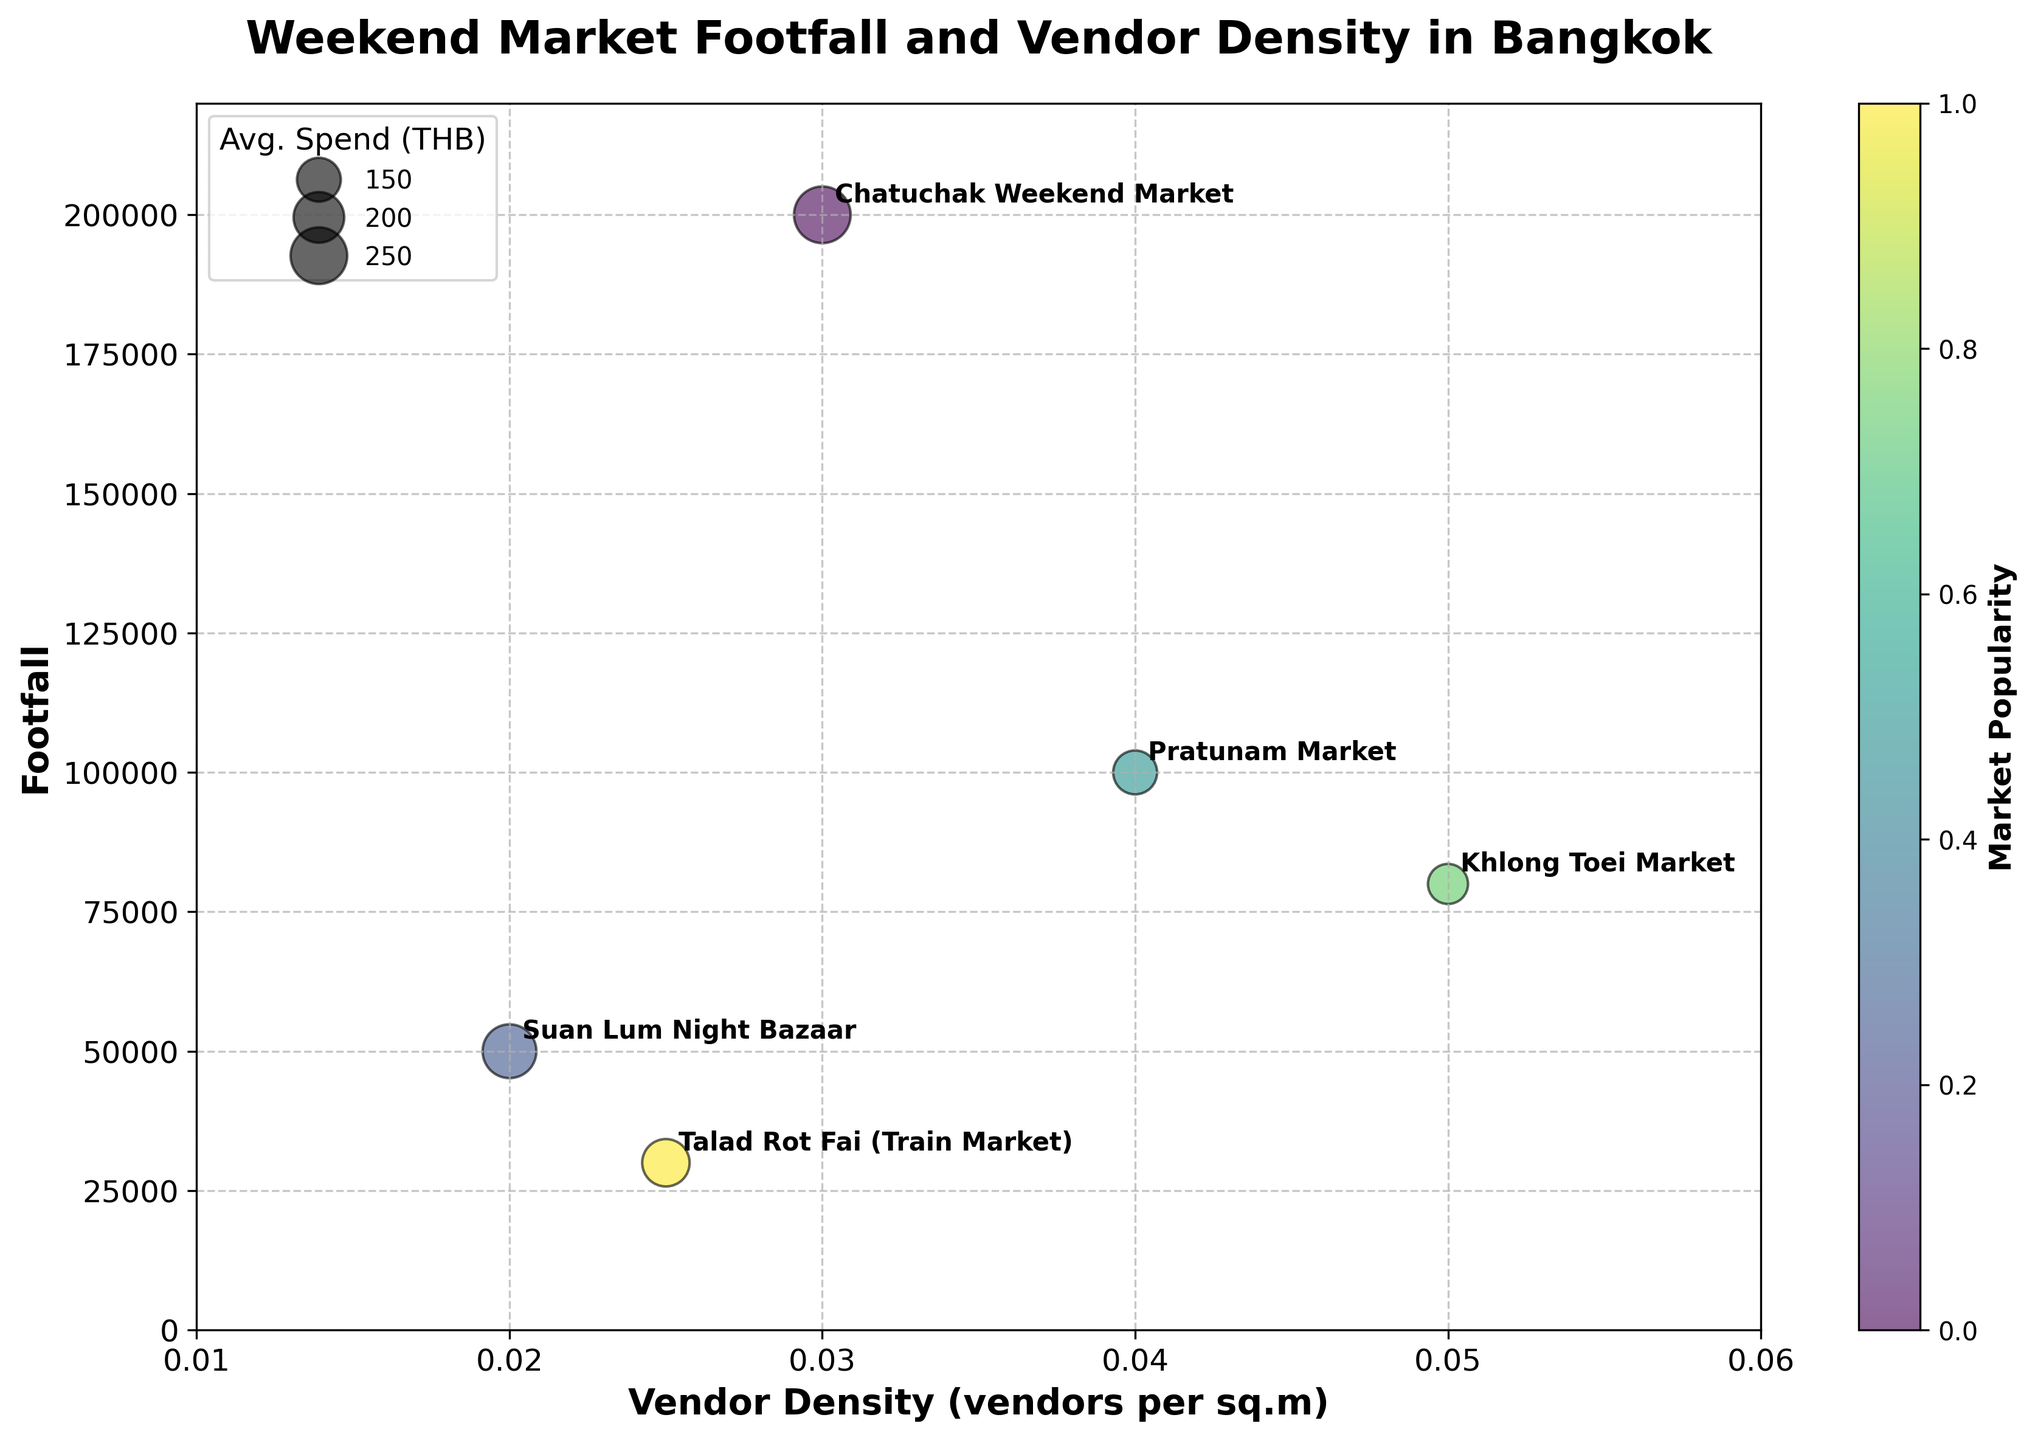What's the market with the highest footfall? Look at the y-axis which represents "Footfall" and check which market's bubble is positioned highest on this axis.
Answer: Chatuchak Weekend Market What's the range of vendor density values? Examine the x-axis labeled "Vendor Density (vendors per sq.m)" and identify the minimum and maximum values shown on the axis.
Answer: 0.01 - 0.06 Which market has the smallest bubble size and what does it represent? Look at the size of the bubbles and identify the smallest one. The size of the bubbles represents "Average Spend (THB)".
Answer: Khlong Toei Market, 250 THB What's the average footfall of all markets combined? Sum all the footfall values and then divide by the number of markets. \((200000 + 50000 + 100000 + 80000 + 30000) / 5 = 460000 / 5\)
Answer: 92000 Which market has the highest vendor density and how does its average spend compare to other markets? Find the bubble closest to the rightmost end of the x-axis labeled "Vendor Density (vendors per sq.m)". Compare its average spend (size of the bubble) to other bubbles.
Answer: Khlong Toei Market, It has the lowest spend (250 THB) compared to others Is there a direct correlation between vendor density and footfall? Observe the general trend of bubbles along the x-axis and y-axis.
Answer: No clear direct correlation Which market(s) have a footfall between 50,000 and 100,000? Identify the bubbles positioned between 50,000 and 100,000 on the y-axis.
Answer: Suan Lum Night Bazaar, Pratunam Market, Khlong Toei Market How does the footfall of Suan Lum Night Bazaar compare to Talad Rot Fai? Find the positions of Suan Lum Night Bazaar and Talad Rot Fai on the y-axis and compare their heights.
Answer: Suan Lum Night Bazaar has higher footfall What do the colors of the bubbles represent in the context of the Bubble Chart? Notice the usage of colors and check the color bar or title/labels for indication.
Answer: Market Popularity Which market has the highest average spend and how is it represented in the plot? Find the largest bubble since bubble size represents average spend and identify the market.
Answer: Chatuchak Weekend Market, represented by the largest bubble 